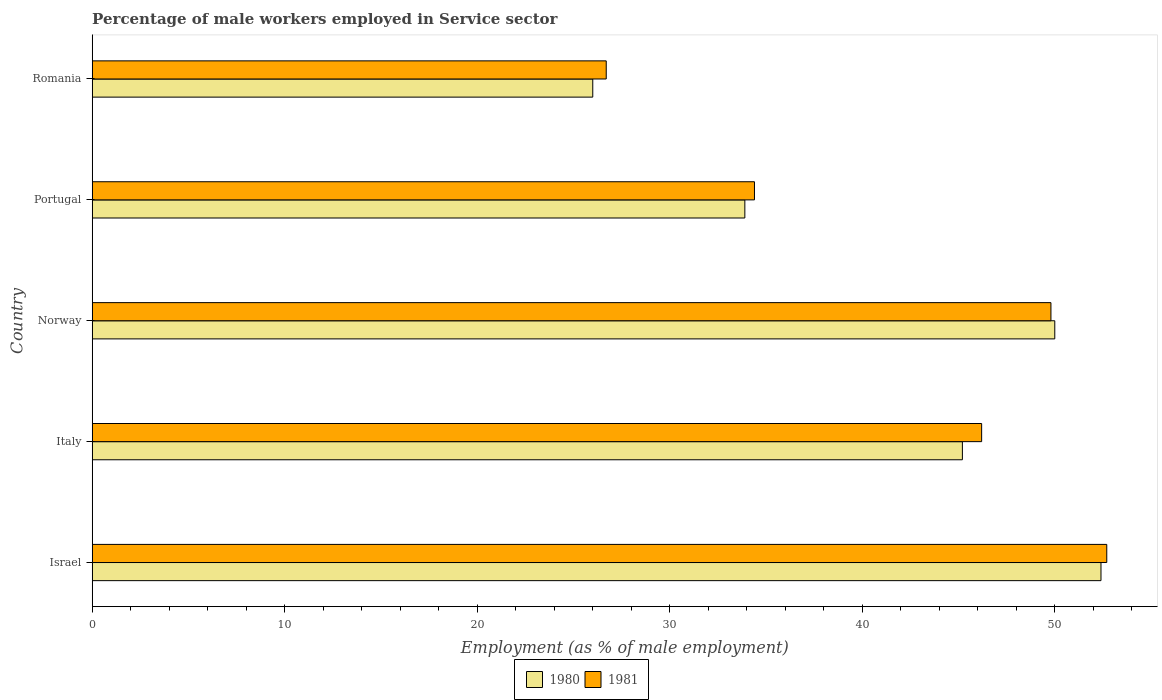How many different coloured bars are there?
Ensure brevity in your answer.  2. How many groups of bars are there?
Provide a succinct answer. 5. How many bars are there on the 5th tick from the top?
Your answer should be very brief. 2. In how many cases, is the number of bars for a given country not equal to the number of legend labels?
Offer a very short reply. 0. What is the percentage of male workers employed in Service sector in 1981 in Portugal?
Your answer should be compact. 34.4. Across all countries, what is the maximum percentage of male workers employed in Service sector in 1981?
Your response must be concise. 52.7. In which country was the percentage of male workers employed in Service sector in 1981 minimum?
Offer a very short reply. Romania. What is the total percentage of male workers employed in Service sector in 1980 in the graph?
Ensure brevity in your answer.  207.5. What is the difference between the percentage of male workers employed in Service sector in 1980 in Portugal and that in Romania?
Ensure brevity in your answer.  7.9. What is the average percentage of male workers employed in Service sector in 1980 per country?
Keep it short and to the point. 41.5. What is the ratio of the percentage of male workers employed in Service sector in 1981 in Israel to that in Norway?
Make the answer very short. 1.06. Is the percentage of male workers employed in Service sector in 1980 in Portugal less than that in Romania?
Your answer should be very brief. No. What is the difference between the highest and the second highest percentage of male workers employed in Service sector in 1980?
Your answer should be very brief. 2.4. What is the difference between the highest and the lowest percentage of male workers employed in Service sector in 1980?
Make the answer very short. 26.4. Is the sum of the percentage of male workers employed in Service sector in 1980 in Israel and Norway greater than the maximum percentage of male workers employed in Service sector in 1981 across all countries?
Provide a succinct answer. Yes. What does the 2nd bar from the bottom in Italy represents?
Your answer should be compact. 1981. How many countries are there in the graph?
Your answer should be compact. 5. Are the values on the major ticks of X-axis written in scientific E-notation?
Your response must be concise. No. Where does the legend appear in the graph?
Your response must be concise. Bottom center. How are the legend labels stacked?
Give a very brief answer. Horizontal. What is the title of the graph?
Keep it short and to the point. Percentage of male workers employed in Service sector. What is the label or title of the X-axis?
Your response must be concise. Employment (as % of male employment). What is the label or title of the Y-axis?
Ensure brevity in your answer.  Country. What is the Employment (as % of male employment) of 1980 in Israel?
Make the answer very short. 52.4. What is the Employment (as % of male employment) of 1981 in Israel?
Your answer should be very brief. 52.7. What is the Employment (as % of male employment) in 1980 in Italy?
Your response must be concise. 45.2. What is the Employment (as % of male employment) in 1981 in Italy?
Your answer should be very brief. 46.2. What is the Employment (as % of male employment) in 1981 in Norway?
Your answer should be compact. 49.8. What is the Employment (as % of male employment) of 1980 in Portugal?
Provide a short and direct response. 33.9. What is the Employment (as % of male employment) of 1981 in Portugal?
Provide a short and direct response. 34.4. What is the Employment (as % of male employment) of 1981 in Romania?
Your answer should be very brief. 26.7. Across all countries, what is the maximum Employment (as % of male employment) of 1980?
Offer a very short reply. 52.4. Across all countries, what is the maximum Employment (as % of male employment) in 1981?
Your answer should be very brief. 52.7. Across all countries, what is the minimum Employment (as % of male employment) in 1981?
Your answer should be very brief. 26.7. What is the total Employment (as % of male employment) in 1980 in the graph?
Keep it short and to the point. 207.5. What is the total Employment (as % of male employment) of 1981 in the graph?
Your response must be concise. 209.8. What is the difference between the Employment (as % of male employment) in 1981 in Israel and that in Italy?
Keep it short and to the point. 6.5. What is the difference between the Employment (as % of male employment) in 1980 in Israel and that in Norway?
Your response must be concise. 2.4. What is the difference between the Employment (as % of male employment) of 1981 in Israel and that in Norway?
Ensure brevity in your answer.  2.9. What is the difference between the Employment (as % of male employment) of 1980 in Israel and that in Portugal?
Offer a very short reply. 18.5. What is the difference between the Employment (as % of male employment) of 1980 in Israel and that in Romania?
Provide a short and direct response. 26.4. What is the difference between the Employment (as % of male employment) of 1981 in Italy and that in Norway?
Keep it short and to the point. -3.6. What is the difference between the Employment (as % of male employment) in 1980 in Italy and that in Portugal?
Offer a very short reply. 11.3. What is the difference between the Employment (as % of male employment) in 1980 in Italy and that in Romania?
Provide a succinct answer. 19.2. What is the difference between the Employment (as % of male employment) in 1981 in Norway and that in Portugal?
Ensure brevity in your answer.  15.4. What is the difference between the Employment (as % of male employment) in 1981 in Norway and that in Romania?
Ensure brevity in your answer.  23.1. What is the difference between the Employment (as % of male employment) of 1981 in Portugal and that in Romania?
Make the answer very short. 7.7. What is the difference between the Employment (as % of male employment) in 1980 in Israel and the Employment (as % of male employment) in 1981 in Italy?
Make the answer very short. 6.2. What is the difference between the Employment (as % of male employment) of 1980 in Israel and the Employment (as % of male employment) of 1981 in Norway?
Make the answer very short. 2.6. What is the difference between the Employment (as % of male employment) in 1980 in Israel and the Employment (as % of male employment) in 1981 in Portugal?
Your response must be concise. 18. What is the difference between the Employment (as % of male employment) of 1980 in Israel and the Employment (as % of male employment) of 1981 in Romania?
Provide a succinct answer. 25.7. What is the difference between the Employment (as % of male employment) in 1980 in Italy and the Employment (as % of male employment) in 1981 in Portugal?
Make the answer very short. 10.8. What is the difference between the Employment (as % of male employment) in 1980 in Norway and the Employment (as % of male employment) in 1981 in Romania?
Your answer should be very brief. 23.3. What is the average Employment (as % of male employment) in 1980 per country?
Give a very brief answer. 41.5. What is the average Employment (as % of male employment) of 1981 per country?
Give a very brief answer. 41.96. What is the difference between the Employment (as % of male employment) in 1980 and Employment (as % of male employment) in 1981 in Italy?
Offer a very short reply. -1. What is the difference between the Employment (as % of male employment) in 1980 and Employment (as % of male employment) in 1981 in Norway?
Ensure brevity in your answer.  0.2. What is the difference between the Employment (as % of male employment) in 1980 and Employment (as % of male employment) in 1981 in Portugal?
Offer a terse response. -0.5. What is the ratio of the Employment (as % of male employment) in 1980 in Israel to that in Italy?
Offer a terse response. 1.16. What is the ratio of the Employment (as % of male employment) of 1981 in Israel to that in Italy?
Ensure brevity in your answer.  1.14. What is the ratio of the Employment (as % of male employment) of 1980 in Israel to that in Norway?
Ensure brevity in your answer.  1.05. What is the ratio of the Employment (as % of male employment) in 1981 in Israel to that in Norway?
Keep it short and to the point. 1.06. What is the ratio of the Employment (as % of male employment) of 1980 in Israel to that in Portugal?
Make the answer very short. 1.55. What is the ratio of the Employment (as % of male employment) of 1981 in Israel to that in Portugal?
Your response must be concise. 1.53. What is the ratio of the Employment (as % of male employment) of 1980 in Israel to that in Romania?
Keep it short and to the point. 2.02. What is the ratio of the Employment (as % of male employment) in 1981 in Israel to that in Romania?
Ensure brevity in your answer.  1.97. What is the ratio of the Employment (as % of male employment) of 1980 in Italy to that in Norway?
Keep it short and to the point. 0.9. What is the ratio of the Employment (as % of male employment) of 1981 in Italy to that in Norway?
Provide a short and direct response. 0.93. What is the ratio of the Employment (as % of male employment) in 1980 in Italy to that in Portugal?
Keep it short and to the point. 1.33. What is the ratio of the Employment (as % of male employment) in 1981 in Italy to that in Portugal?
Your answer should be very brief. 1.34. What is the ratio of the Employment (as % of male employment) of 1980 in Italy to that in Romania?
Offer a very short reply. 1.74. What is the ratio of the Employment (as % of male employment) of 1981 in Italy to that in Romania?
Give a very brief answer. 1.73. What is the ratio of the Employment (as % of male employment) of 1980 in Norway to that in Portugal?
Keep it short and to the point. 1.47. What is the ratio of the Employment (as % of male employment) in 1981 in Norway to that in Portugal?
Your response must be concise. 1.45. What is the ratio of the Employment (as % of male employment) in 1980 in Norway to that in Romania?
Make the answer very short. 1.92. What is the ratio of the Employment (as % of male employment) in 1981 in Norway to that in Romania?
Offer a very short reply. 1.87. What is the ratio of the Employment (as % of male employment) of 1980 in Portugal to that in Romania?
Provide a succinct answer. 1.3. What is the ratio of the Employment (as % of male employment) in 1981 in Portugal to that in Romania?
Ensure brevity in your answer.  1.29. What is the difference between the highest and the lowest Employment (as % of male employment) of 1980?
Give a very brief answer. 26.4. What is the difference between the highest and the lowest Employment (as % of male employment) in 1981?
Give a very brief answer. 26. 